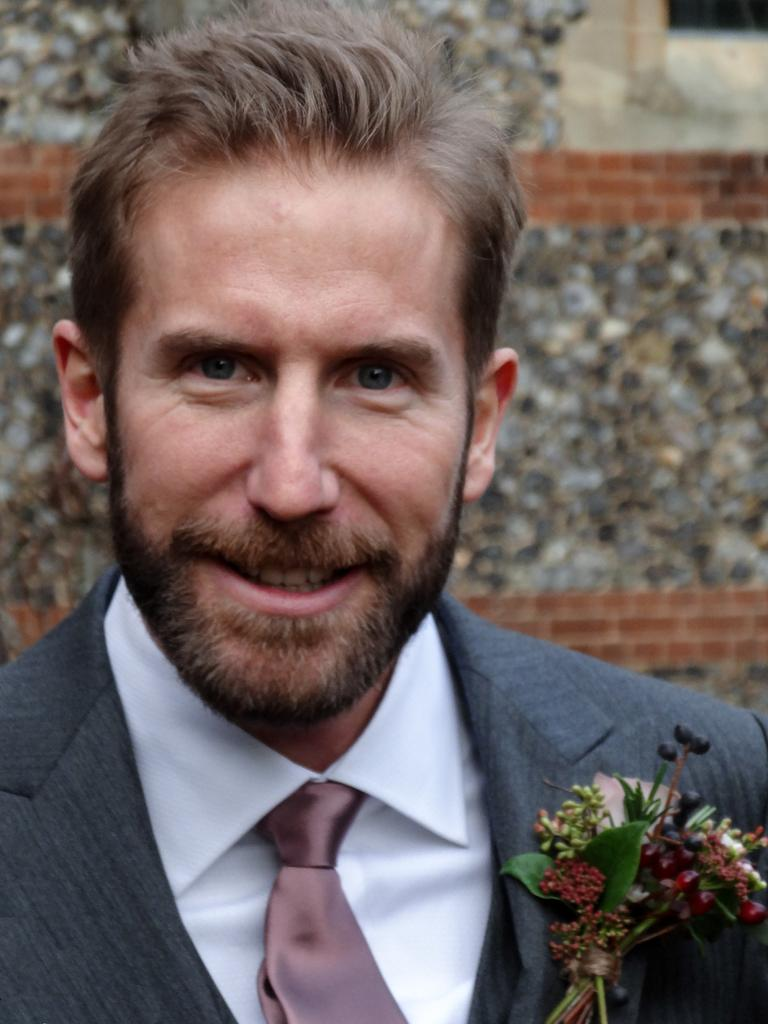Who is present in the image? There is a person in the image. What is the person wearing? The person is wearing a suit. What is the person's facial expression? The person is smiling. What can be seen in the background of the image? There is a wall in the background of the image. What type of honey is being served in the image? There is no honey present in the image. How is the person contributing to world peace in the image? The image does not depict any actions related to world peace. 